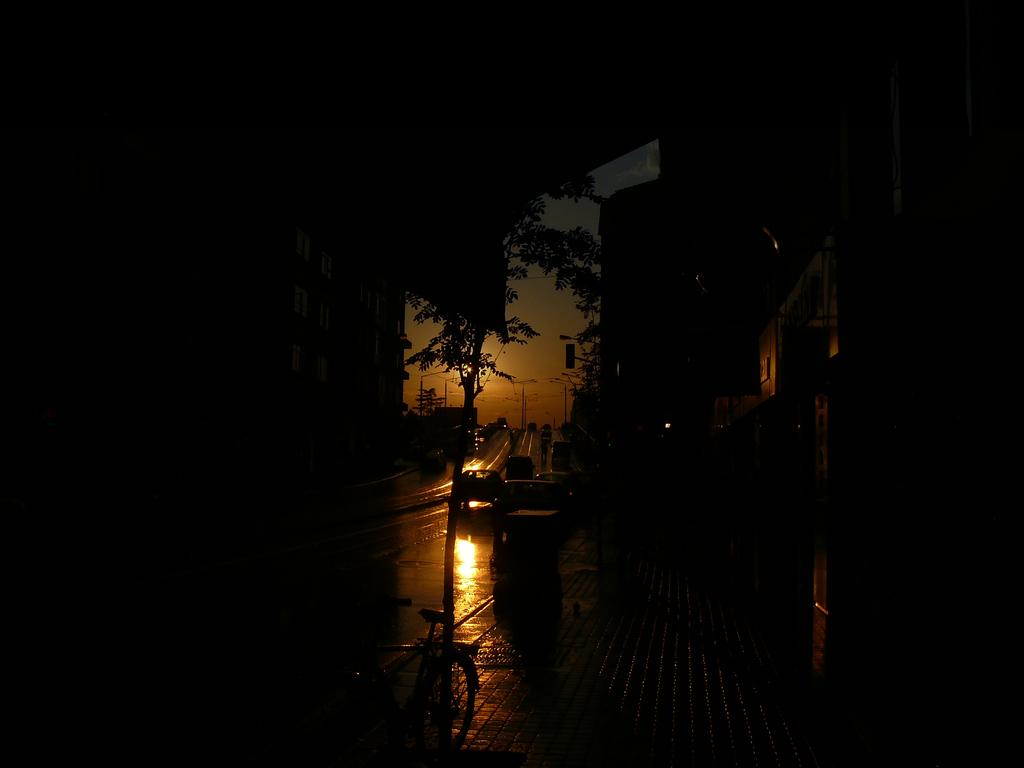What is: What type of transportation is present on the road in the image? There are vehicles on the road in the image. What type of non-motorized transportation is visible in the image? There is a bicycle in the image. What type of structures can be seen in the image? There are buildings in the image. What type of vegetation is present in the image? There are trees in the image. How would you describe the lighting in the image? The image is dark. How many pies are being baked by the carpenter in the image? There is no carpenter or pies present in the image. What type of bed is visible in the image? There is no bed present in the image. 